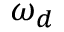Convert formula to latex. <formula><loc_0><loc_0><loc_500><loc_500>\omega _ { d }</formula> 